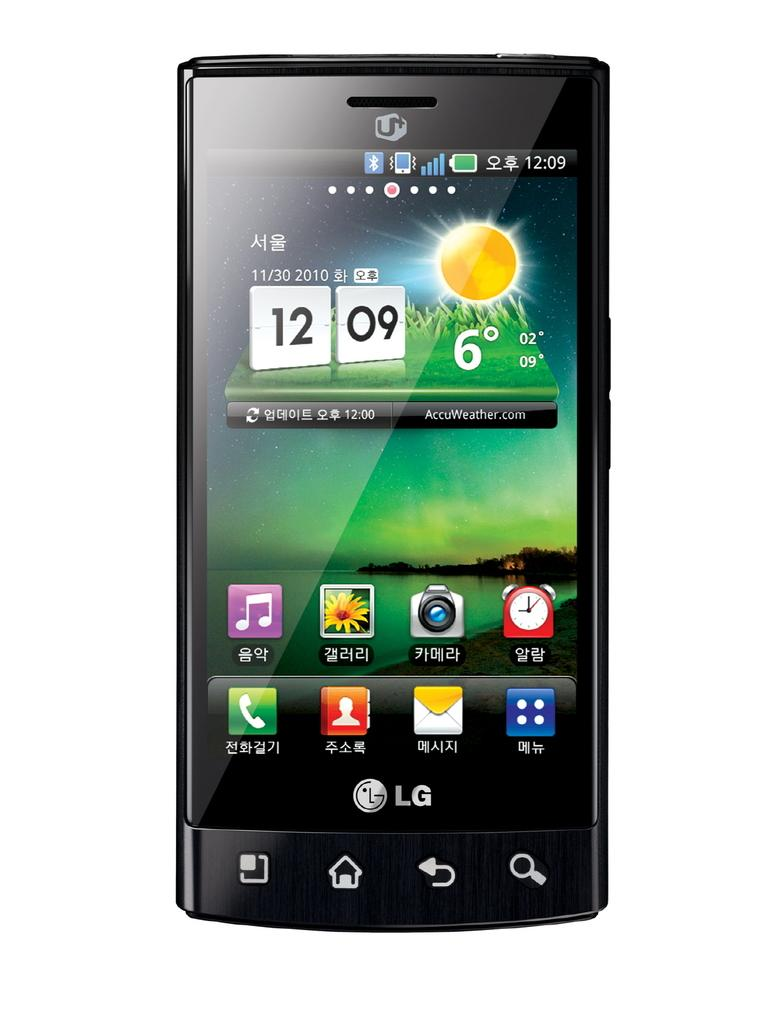<image>
Summarize the visual content of the image. An LG phone shows that it is 12:09 on November 30th. 